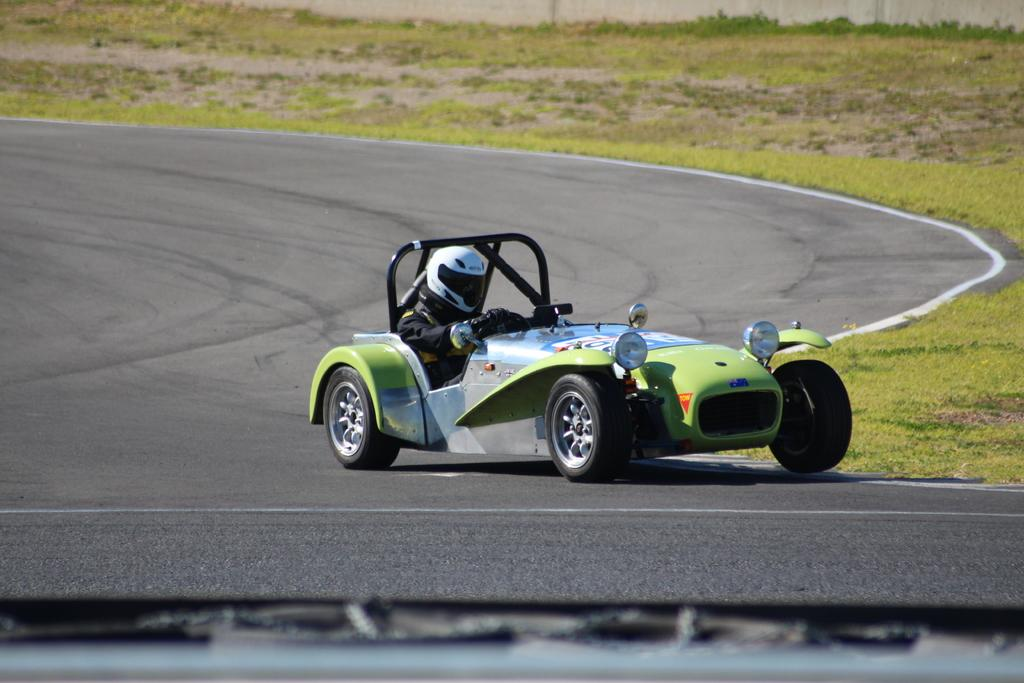What is the main subject in the center of the image? There is a racing car in the center of the image. Is there anyone inside the racing car? Yes, there is a person sitting inside the car. What can be seen in the background of the image? There is grass in the background of the image. What type of sticks are being used to play baseball in the image? There is no baseball or sticks present in the image; it features a racing car with a person inside and grass in the background. 